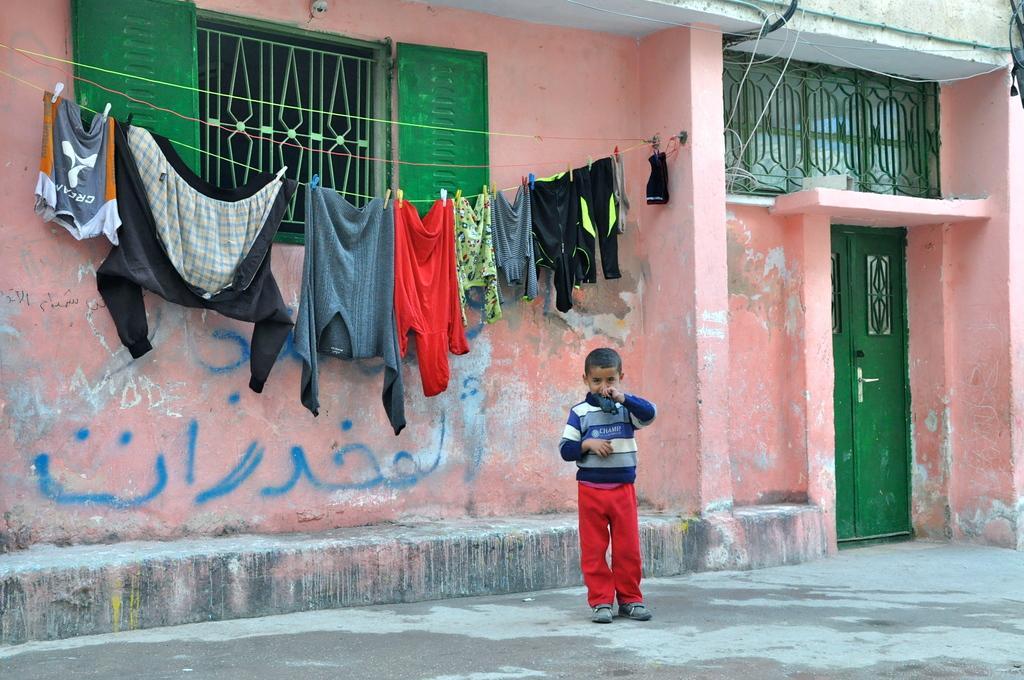Can you describe this image briefly? Here in this picture we can see a child standing on the ground and behind him we can see a house present and we can also see a window and a door present and on the wall we can see clothes hanging on a rope and we can see some text written on the wall. 